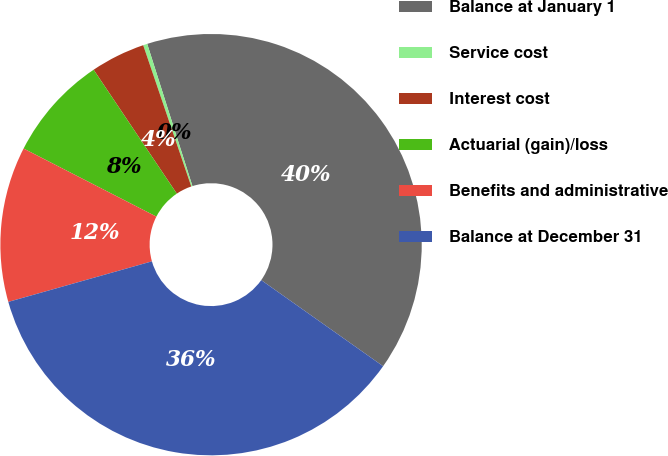Convert chart. <chart><loc_0><loc_0><loc_500><loc_500><pie_chart><fcel>Balance at January 1<fcel>Service cost<fcel>Interest cost<fcel>Actuarial (gain)/loss<fcel>Benefits and administrative<fcel>Balance at December 31<nl><fcel>39.69%<fcel>0.32%<fcel>4.19%<fcel>8.05%<fcel>11.92%<fcel>35.83%<nl></chart> 